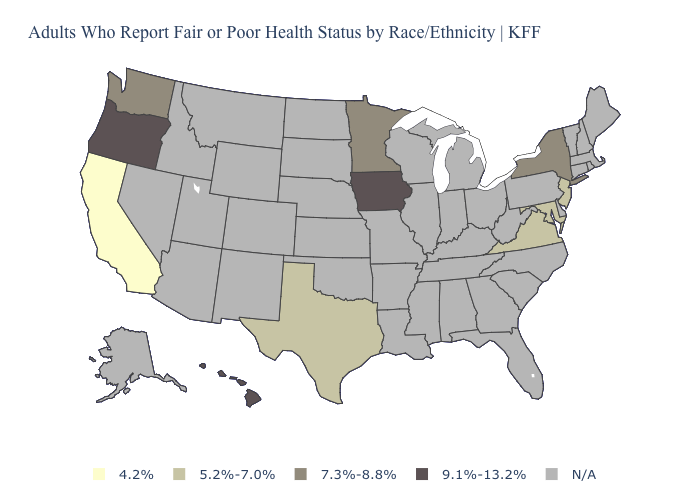Does Texas have the highest value in the USA?
Give a very brief answer. No. What is the value of Massachusetts?
Be succinct. N/A. Among the states that border Kentucky , which have the highest value?
Be succinct. Virginia. Does the first symbol in the legend represent the smallest category?
Concise answer only. Yes. Which states have the highest value in the USA?
Keep it brief. Hawaii, Iowa, Oregon. What is the highest value in the West ?
Keep it brief. 9.1%-13.2%. What is the value of South Carolina?
Short answer required. N/A. What is the value of Massachusetts?
Write a very short answer. N/A. What is the highest value in the West ?
Keep it brief. 9.1%-13.2%. Which states have the lowest value in the USA?
Be succinct. California. What is the lowest value in states that border North Dakota?
Concise answer only. 7.3%-8.8%. What is the highest value in states that border Louisiana?
Answer briefly. 5.2%-7.0%. 